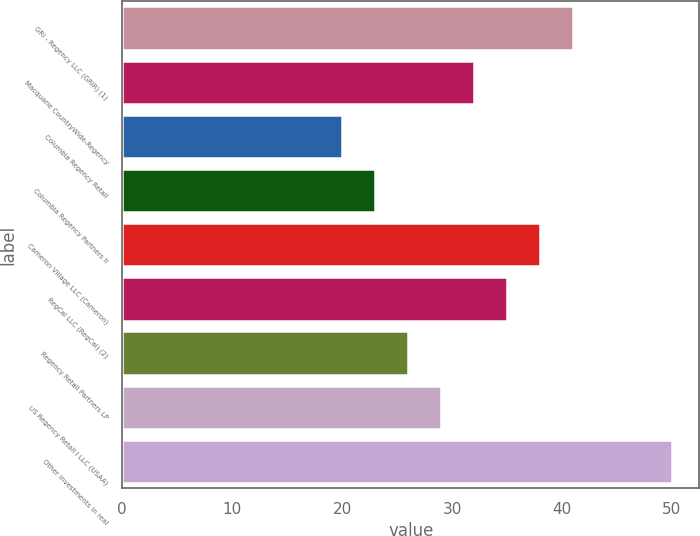<chart> <loc_0><loc_0><loc_500><loc_500><bar_chart><fcel>GRI - Regency LLC (GRIR) (1)<fcel>Macquarie CountryWide-Regency<fcel>Columbia Regency Retail<fcel>Columbia Regency Partners II<fcel>Cameron Village LLC (Cameron)<fcel>RegCal LLC (RegCal) (2)<fcel>Regency Retail Partners LP<fcel>US Regency Retail I LLC (USAA)<fcel>Other investments in real<nl><fcel>41<fcel>32<fcel>20<fcel>23<fcel>38<fcel>35<fcel>26<fcel>29<fcel>50<nl></chart> 